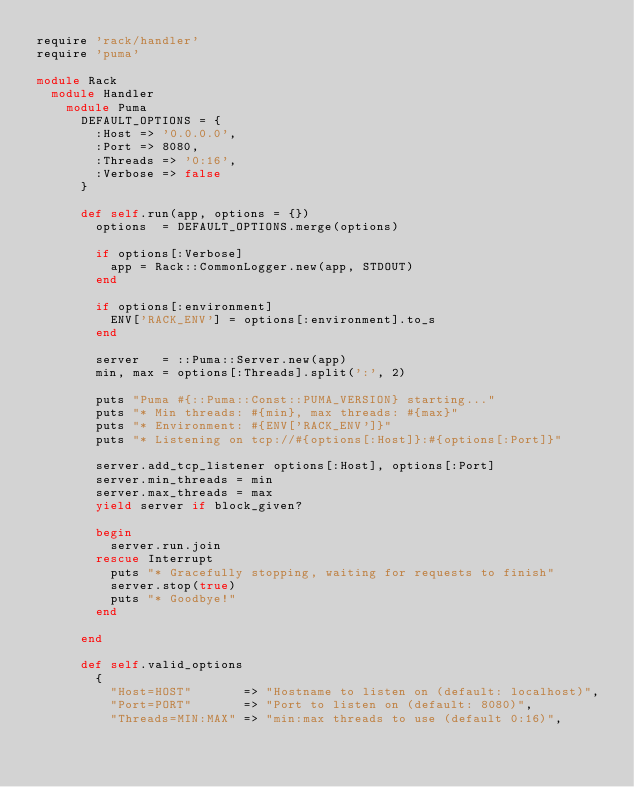<code> <loc_0><loc_0><loc_500><loc_500><_Ruby_>require 'rack/handler'
require 'puma'

module Rack
  module Handler
    module Puma
      DEFAULT_OPTIONS = {
        :Host => '0.0.0.0',
        :Port => 8080,
        :Threads => '0:16',
        :Verbose => false
      }

      def self.run(app, options = {})
        options  = DEFAULT_OPTIONS.merge(options)

        if options[:Verbose]
          app = Rack::CommonLogger.new(app, STDOUT)
        end

        if options[:environment]
          ENV['RACK_ENV'] = options[:environment].to_s
        end

        server   = ::Puma::Server.new(app)
        min, max = options[:Threads].split(':', 2)

        puts "Puma #{::Puma::Const::PUMA_VERSION} starting..."
        puts "* Min threads: #{min}, max threads: #{max}"
        puts "* Environment: #{ENV['RACK_ENV']}"
        puts "* Listening on tcp://#{options[:Host]}:#{options[:Port]}"

        server.add_tcp_listener options[:Host], options[:Port]
        server.min_threads = min
        server.max_threads = max
        yield server if block_given?

        begin
          server.run.join
        rescue Interrupt
          puts "* Gracefully stopping, waiting for requests to finish"
          server.stop(true)
          puts "* Goodbye!"
        end

      end

      def self.valid_options
        {
          "Host=HOST"       => "Hostname to listen on (default: localhost)",
          "Port=PORT"       => "Port to listen on (default: 8080)",
          "Threads=MIN:MAX" => "min:max threads to use (default 0:16)",</code> 